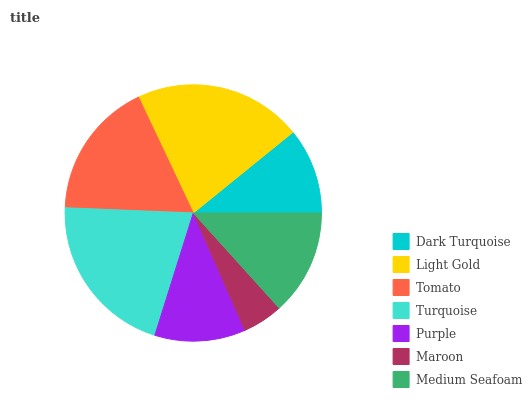Is Maroon the minimum?
Answer yes or no. Yes. Is Light Gold the maximum?
Answer yes or no. Yes. Is Tomato the minimum?
Answer yes or no. No. Is Tomato the maximum?
Answer yes or no. No. Is Light Gold greater than Tomato?
Answer yes or no. Yes. Is Tomato less than Light Gold?
Answer yes or no. Yes. Is Tomato greater than Light Gold?
Answer yes or no. No. Is Light Gold less than Tomato?
Answer yes or no. No. Is Medium Seafoam the high median?
Answer yes or no. Yes. Is Medium Seafoam the low median?
Answer yes or no. Yes. Is Light Gold the high median?
Answer yes or no. No. Is Maroon the low median?
Answer yes or no. No. 